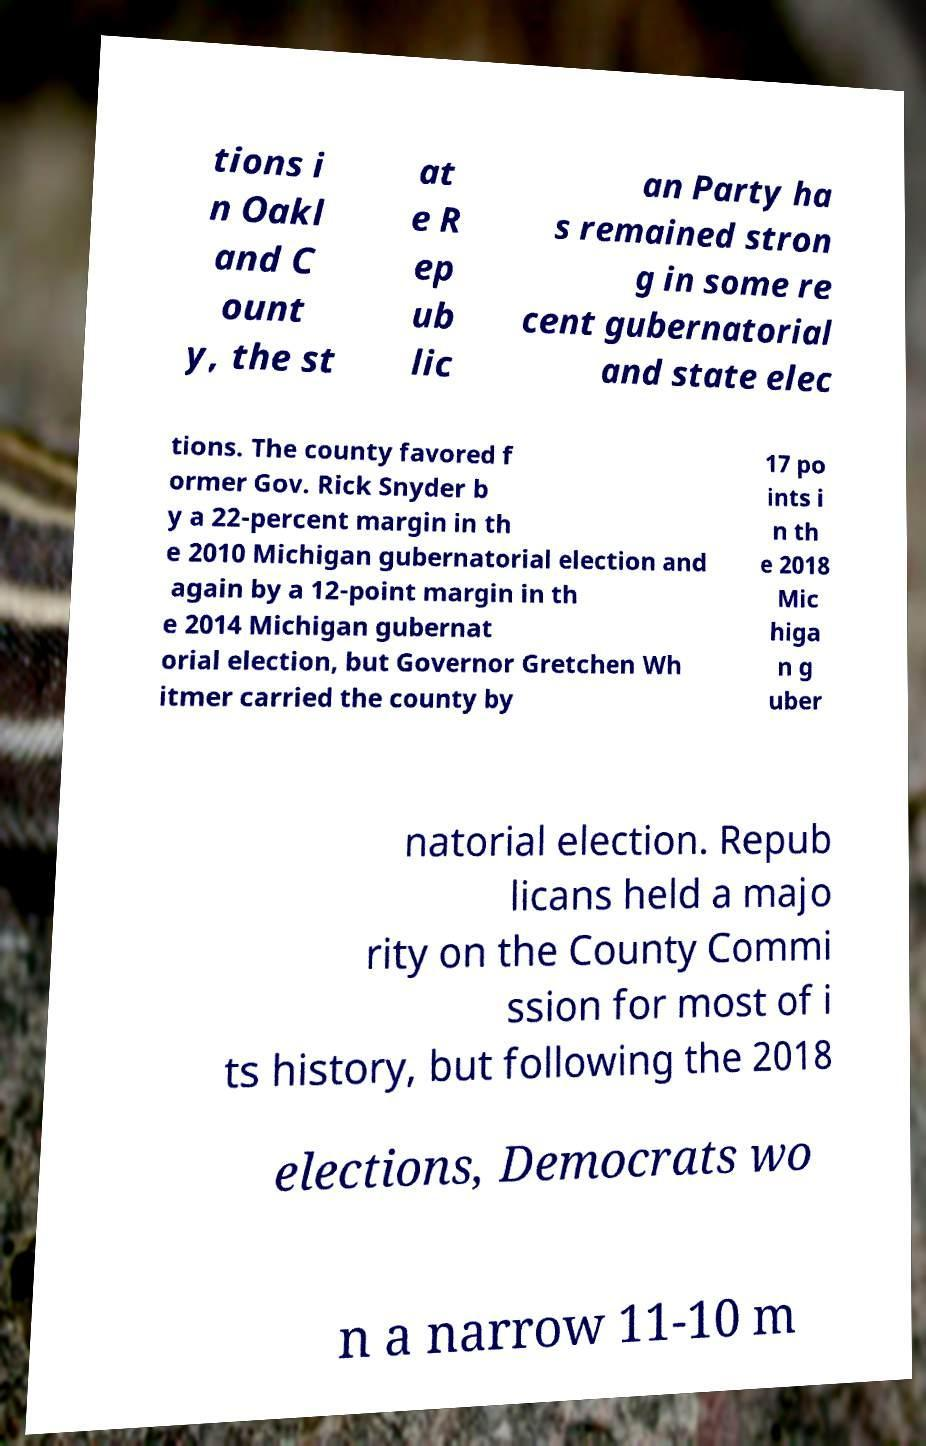What messages or text are displayed in this image? I need them in a readable, typed format. tions i n Oakl and C ount y, the st at e R ep ub lic an Party ha s remained stron g in some re cent gubernatorial and state elec tions. The county favored f ormer Gov. Rick Snyder b y a 22-percent margin in th e 2010 Michigan gubernatorial election and again by a 12-point margin in th e 2014 Michigan gubernat orial election, but Governor Gretchen Wh itmer carried the county by 17 po ints i n th e 2018 Mic higa n g uber natorial election. Repub licans held a majo rity on the County Commi ssion for most of i ts history, but following the 2018 elections, Democrats wo n a narrow 11-10 m 